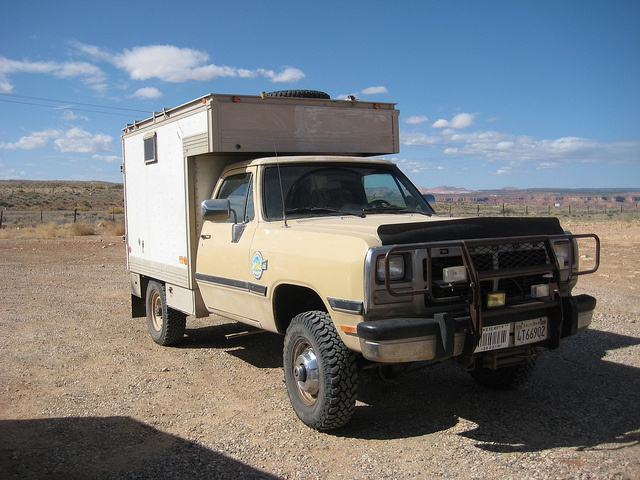Describe the objects in this image and their specific colors. I can see a truck in gray, black, ivory, and tan tones in this image. 